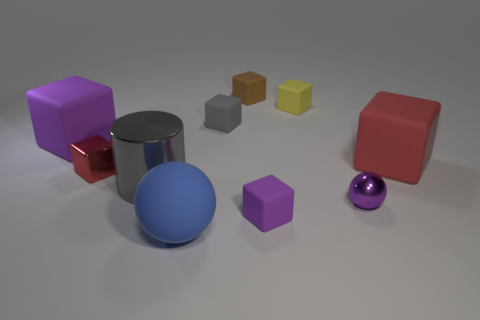Are there more small brown matte blocks than brown rubber cylinders?
Offer a very short reply. Yes. There is a object that is in front of the tiny rubber thing in front of the large matte object to the right of the tiny gray block; what is it made of?
Offer a terse response. Rubber. Is there a big thing that has the same color as the small metal cube?
Make the answer very short. Yes. There is a brown matte object that is the same size as the yellow rubber thing; what shape is it?
Provide a succinct answer. Cube. Is the number of tiny brown rubber blocks less than the number of tiny cyan matte blocks?
Offer a terse response. No. What number of purple matte blocks are the same size as the blue object?
Ensure brevity in your answer.  1. The object that is the same color as the tiny metal cube is what shape?
Make the answer very short. Cube. What is the big ball made of?
Your answer should be very brief. Rubber. There is a red thing on the left side of the yellow matte thing; what is its size?
Ensure brevity in your answer.  Small. What number of large purple things have the same shape as the tiny brown rubber thing?
Your response must be concise. 1. 